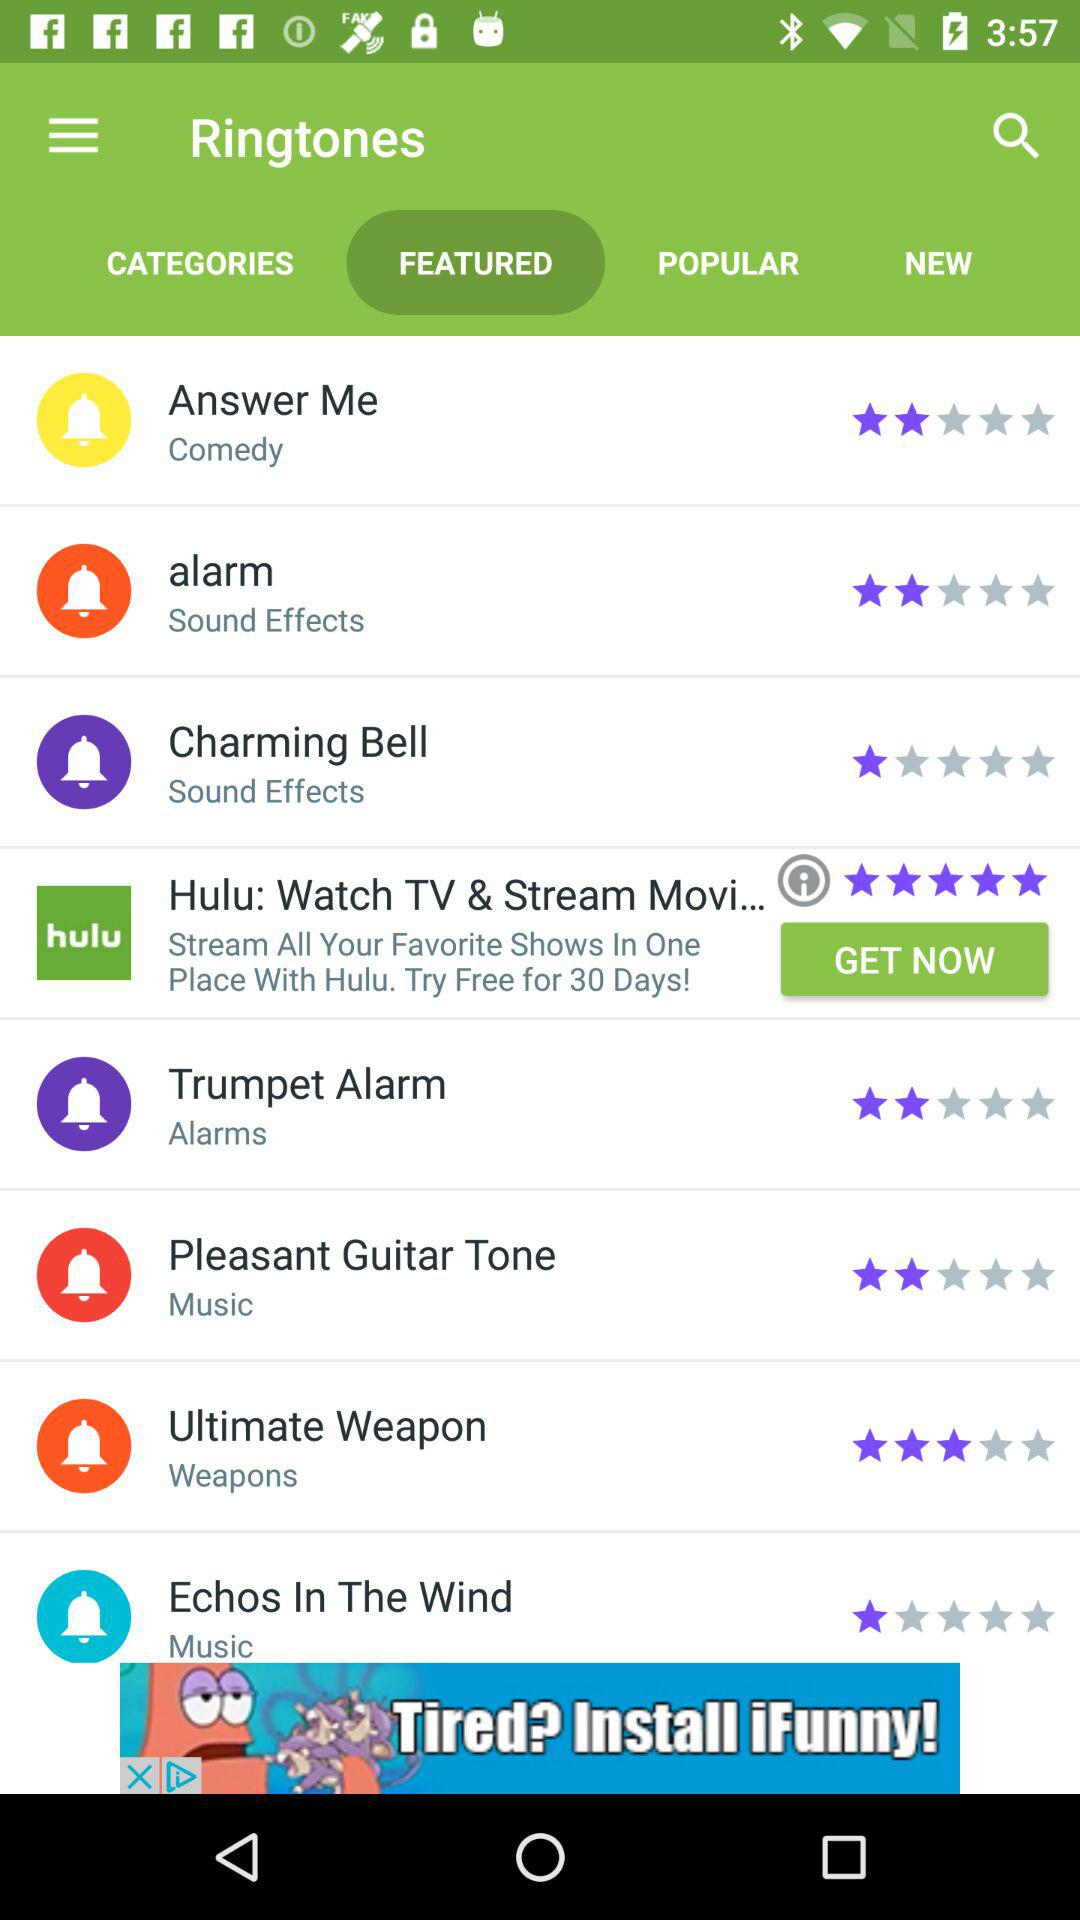Which tab is selected? The selected tab is "FEATURED". 